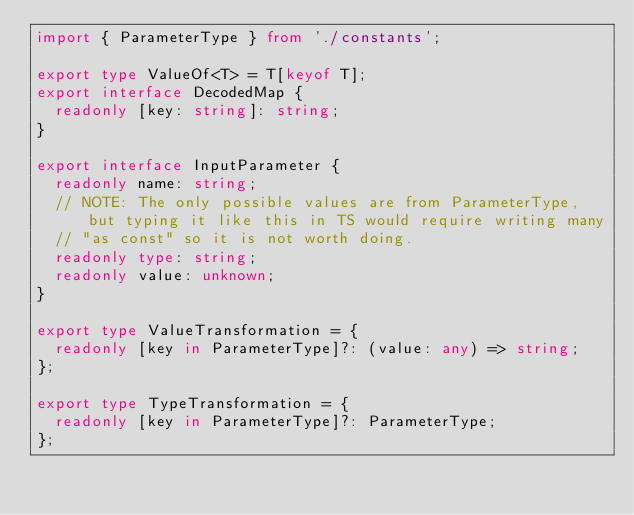<code> <loc_0><loc_0><loc_500><loc_500><_TypeScript_>import { ParameterType } from './constants';

export type ValueOf<T> = T[keyof T];
export interface DecodedMap {
  readonly [key: string]: string;
}

export interface InputParameter {
  readonly name: string;
  // NOTE: The only possible values are from ParameterType, but typing it like this in TS would require writing many
  // "as const" so it is not worth doing.
  readonly type: string;
  readonly value: unknown;
}

export type ValueTransformation = {
  readonly [key in ParameterType]?: (value: any) => string;
};

export type TypeTransformation = {
  readonly [key in ParameterType]?: ParameterType;
};
</code> 